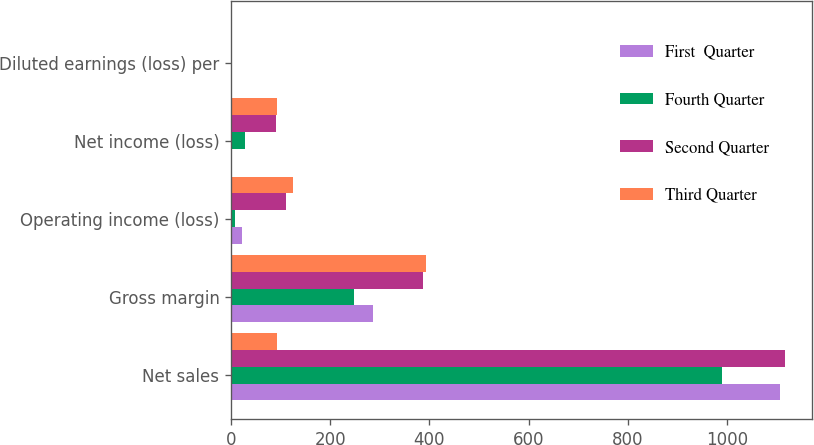<chart> <loc_0><loc_0><loc_500><loc_500><stacked_bar_chart><ecel><fcel>Net sales<fcel>Gross margin<fcel>Operating income (loss)<fcel>Net income (loss)<fcel>Diluted earnings (loss) per<nl><fcel>First  Quarter<fcel>1107.2<fcel>286<fcel>21.7<fcel>1.1<fcel>0<nl><fcel>Fourth Quarter<fcel>991<fcel>248.2<fcel>7.1<fcel>28.3<fcel>0.04<nl><fcel>Second Quarter<fcel>1116.8<fcel>387.9<fcel>109.7<fcel>90.9<fcel>0.13<nl><fcel>Third Quarter<fcel>93.5<fcel>392.6<fcel>125.4<fcel>93.5<fcel>0.14<nl></chart> 